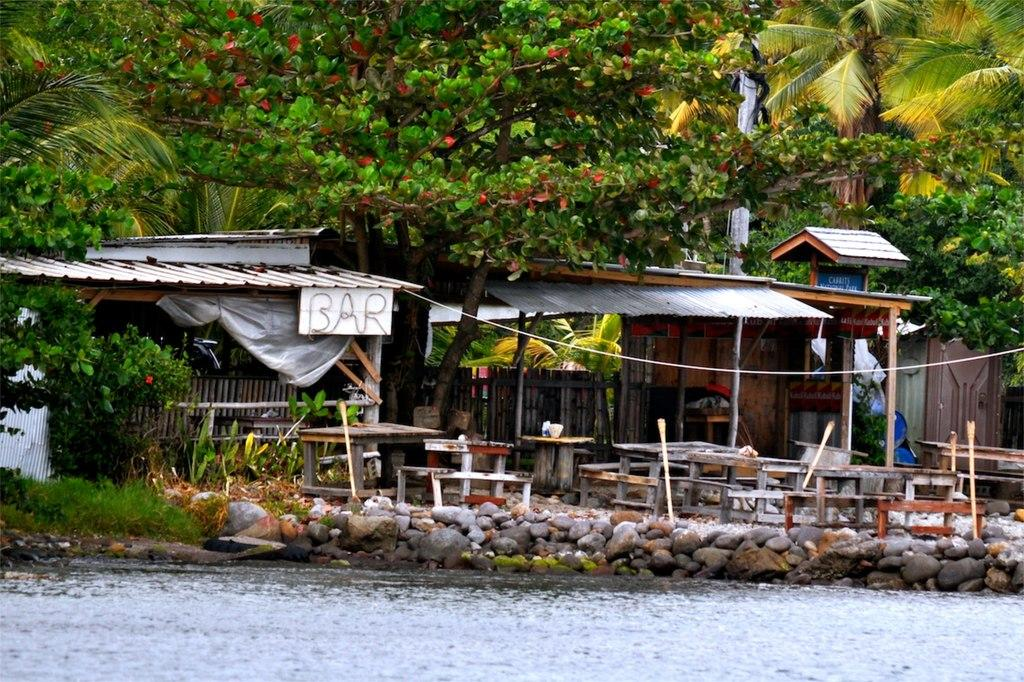What type of natural body of water is present in the image? There is a lake in the image. What other natural elements can be seen in the image? There are rocks and stones, plants, and trees in the image. What type of establishment is visible in the image? There is a restaurant in the image. What furniture is present in the restaurant? There are tables and chairs in the restaurant. What is the texture of the lizards' skin in the image? There are no lizards present in the image, so we cannot determine the texture of their skin. 